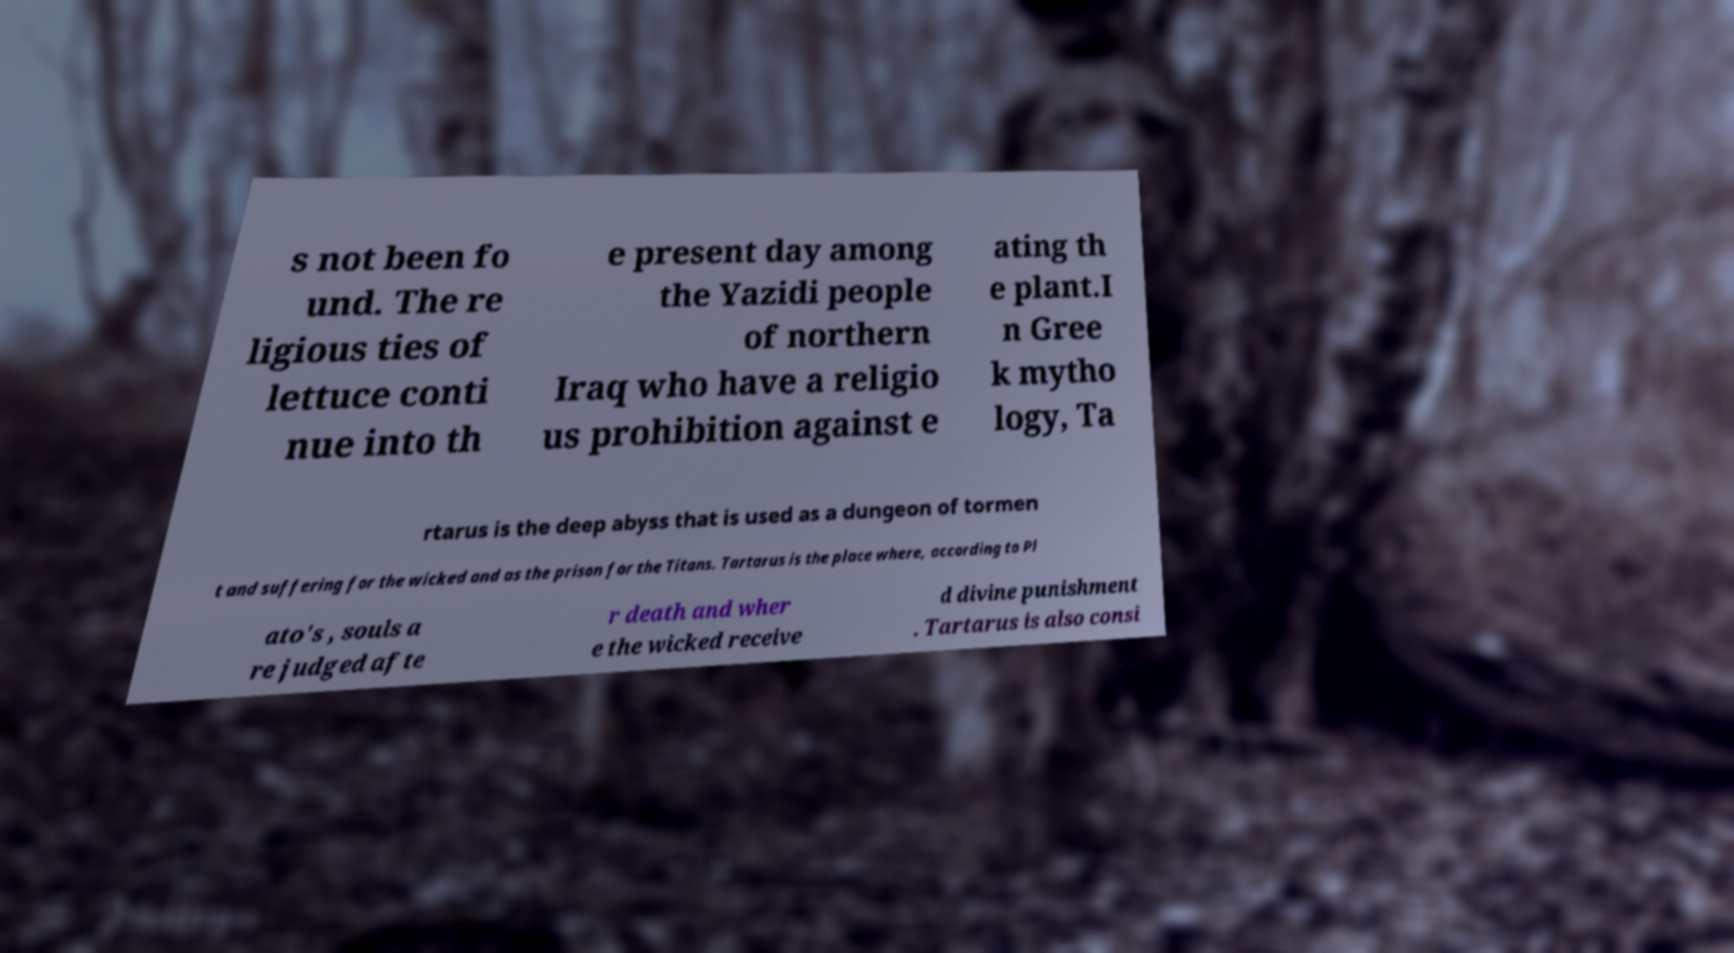Can you read and provide the text displayed in the image?This photo seems to have some interesting text. Can you extract and type it out for me? s not been fo und. The re ligious ties of lettuce conti nue into th e present day among the Yazidi people of northern Iraq who have a religio us prohibition against e ating th e plant.I n Gree k mytho logy, Ta rtarus is the deep abyss that is used as a dungeon of tormen t and suffering for the wicked and as the prison for the Titans. Tartarus is the place where, according to Pl ato's , souls a re judged afte r death and wher e the wicked receive d divine punishment . Tartarus is also consi 